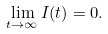Convert formula to latex. <formula><loc_0><loc_0><loc_500><loc_500>\lim _ { t \to \infty } I ( t ) = 0 .</formula> 